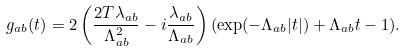Convert formula to latex. <formula><loc_0><loc_0><loc_500><loc_500>g _ { a b } ( t ) = 2 \left ( \frac { 2 T \lambda _ { a b } } { \Lambda _ { a b } ^ { 2 } } - i \frac { \lambda _ { a b } } { \Lambda _ { a b } } \right ) ( \exp ( - \Lambda _ { a b } | t | ) + \Lambda _ { a b } t - 1 ) .</formula> 